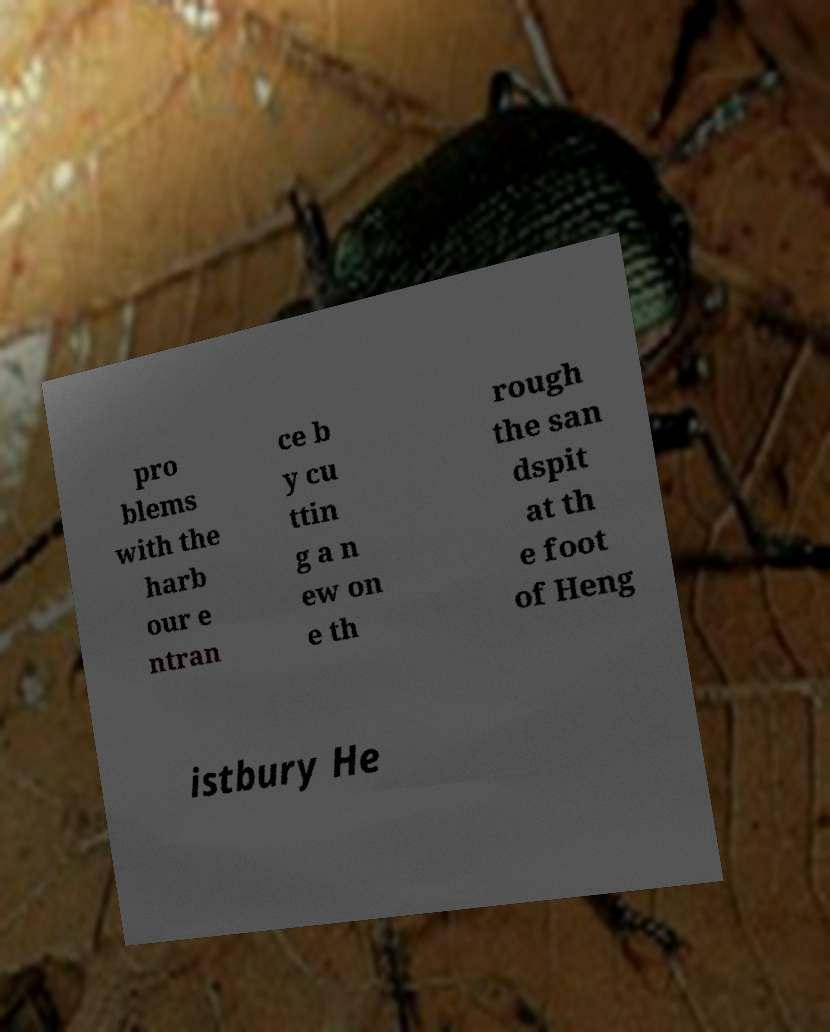I need the written content from this picture converted into text. Can you do that? pro blems with the harb our e ntran ce b y cu ttin g a n ew on e th rough the san dspit at th e foot of Heng istbury He 